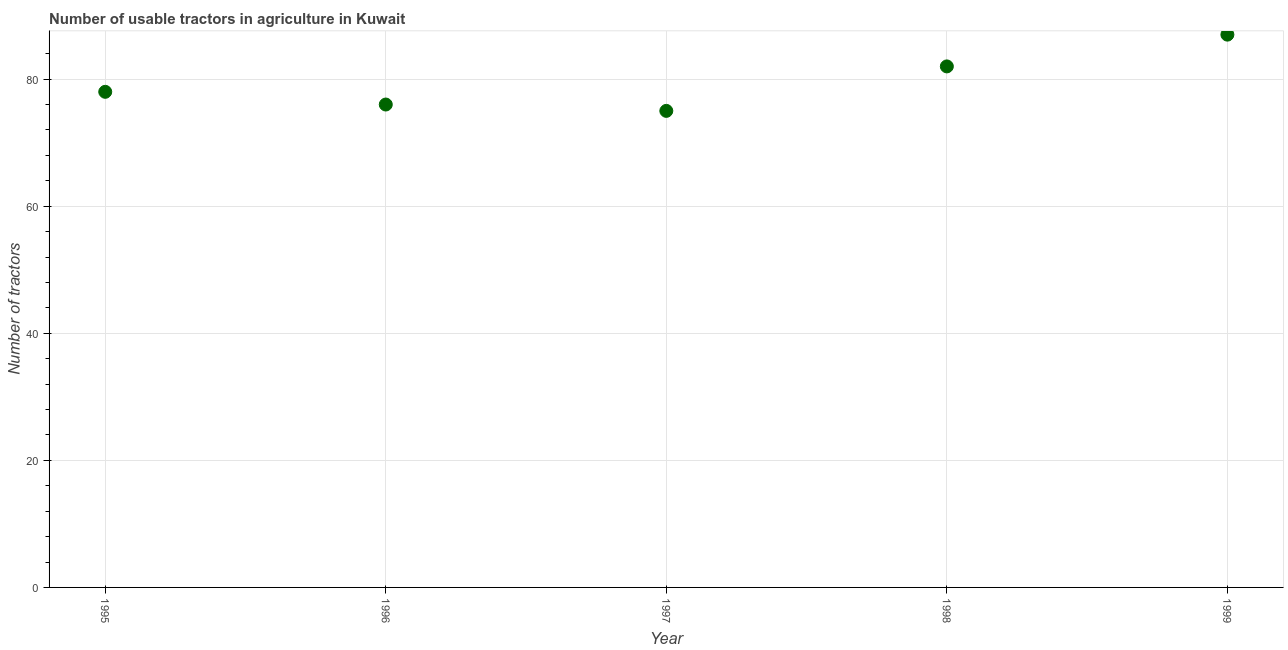What is the number of tractors in 1999?
Keep it short and to the point. 87. Across all years, what is the maximum number of tractors?
Offer a very short reply. 87. Across all years, what is the minimum number of tractors?
Make the answer very short. 75. In which year was the number of tractors maximum?
Offer a terse response. 1999. What is the sum of the number of tractors?
Offer a terse response. 398. What is the difference between the number of tractors in 1995 and 1996?
Your response must be concise. 2. What is the average number of tractors per year?
Offer a very short reply. 79.6. What is the ratio of the number of tractors in 1995 to that in 1998?
Ensure brevity in your answer.  0.95. Is the difference between the number of tractors in 1995 and 1999 greater than the difference between any two years?
Offer a terse response. No. What is the difference between the highest and the second highest number of tractors?
Make the answer very short. 5. What is the difference between the highest and the lowest number of tractors?
Make the answer very short. 12. How many years are there in the graph?
Offer a terse response. 5. What is the difference between two consecutive major ticks on the Y-axis?
Offer a very short reply. 20. Are the values on the major ticks of Y-axis written in scientific E-notation?
Offer a very short reply. No. What is the title of the graph?
Your response must be concise. Number of usable tractors in agriculture in Kuwait. What is the label or title of the X-axis?
Provide a short and direct response. Year. What is the label or title of the Y-axis?
Give a very brief answer. Number of tractors. What is the Number of tractors in 1995?
Keep it short and to the point. 78. What is the Number of tractors in 1996?
Keep it short and to the point. 76. What is the Number of tractors in 1997?
Offer a very short reply. 75. What is the difference between the Number of tractors in 1995 and 1998?
Keep it short and to the point. -4. What is the difference between the Number of tractors in 1996 and 1997?
Provide a short and direct response. 1. What is the difference between the Number of tractors in 1997 and 1998?
Provide a succinct answer. -7. What is the difference between the Number of tractors in 1998 and 1999?
Keep it short and to the point. -5. What is the ratio of the Number of tractors in 1995 to that in 1998?
Give a very brief answer. 0.95. What is the ratio of the Number of tractors in 1995 to that in 1999?
Your response must be concise. 0.9. What is the ratio of the Number of tractors in 1996 to that in 1997?
Your response must be concise. 1.01. What is the ratio of the Number of tractors in 1996 to that in 1998?
Give a very brief answer. 0.93. What is the ratio of the Number of tractors in 1996 to that in 1999?
Give a very brief answer. 0.87. What is the ratio of the Number of tractors in 1997 to that in 1998?
Provide a short and direct response. 0.92. What is the ratio of the Number of tractors in 1997 to that in 1999?
Provide a succinct answer. 0.86. What is the ratio of the Number of tractors in 1998 to that in 1999?
Ensure brevity in your answer.  0.94. 